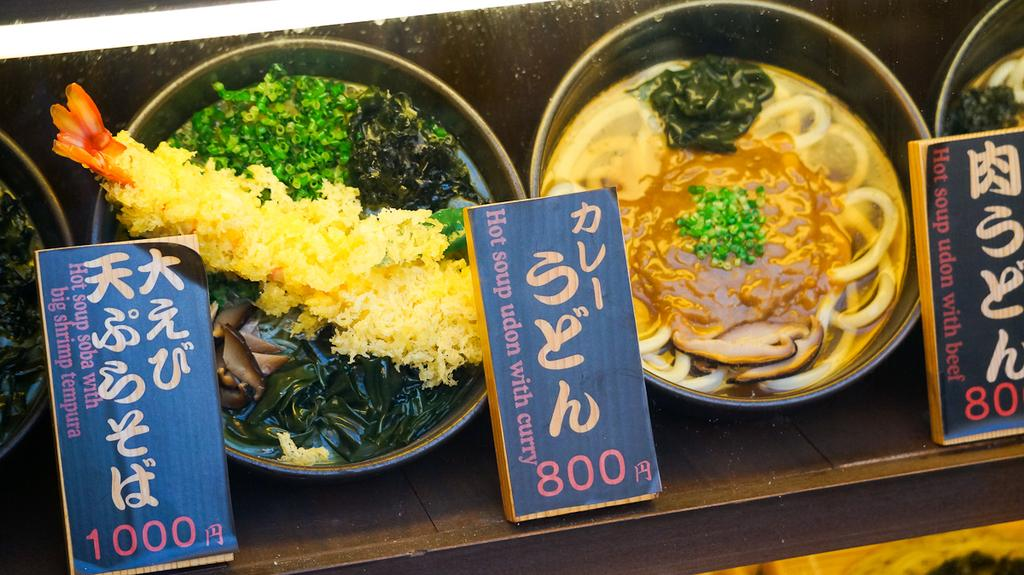What is in the bowls that are visible in the image? There are food items in the bowls in the image. Can you describe any other objects or features in the image? There are boards on an object in the image. What type of eggnog can be seen in the image? There is no eggnog present in the image, let alone eggnog. 